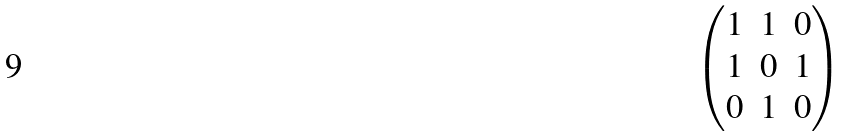<formula> <loc_0><loc_0><loc_500><loc_500>\begin{pmatrix} 1 & 1 & 0 \\ 1 & 0 & 1 \\ 0 & 1 & 0 \end{pmatrix}</formula> 